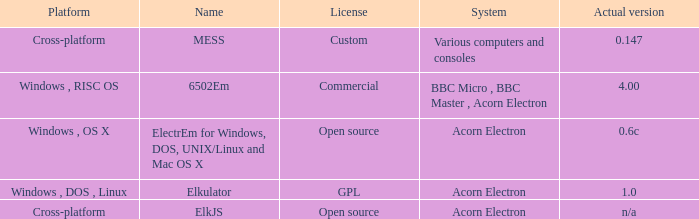What is the name of the platform used for various computers and consoles? Cross-platform. 